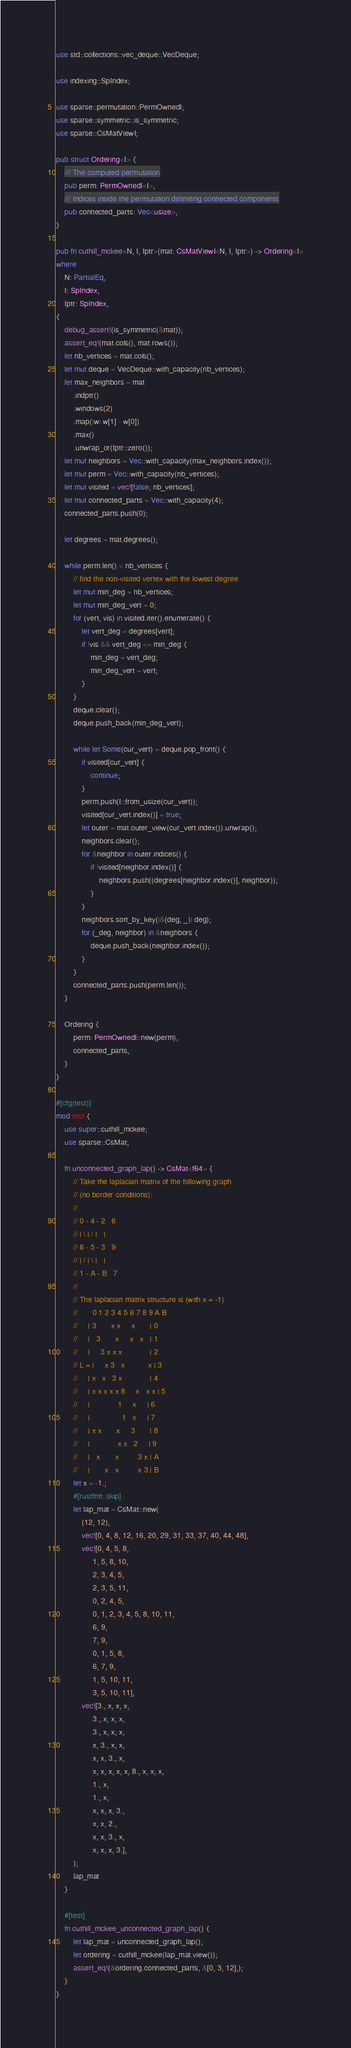Convert code to text. <code><loc_0><loc_0><loc_500><loc_500><_Rust_>use std::collections::vec_deque::VecDeque;

use indexing::SpIndex;

use sparse::permutation::PermOwnedI;
use sparse::symmetric::is_symmetric;
use sparse::CsMatViewI;

pub struct Ordering<I> {
    /// The computed permutation
    pub perm: PermOwnedI<I>,
    /// Indices inside the permutation delimiting connected components
    pub connected_parts: Vec<usize>,
}

pub fn cuthill_mckee<N, I, Iptr>(mat: CsMatViewI<N, I, Iptr>) -> Ordering<I>
where
    N: PartialEq,
    I: SpIndex,
    Iptr: SpIndex,
{
    debug_assert!(is_symmetric(&mat));
    assert_eq!(mat.cols(), mat.rows());
    let nb_vertices = mat.cols();
    let mut deque = VecDeque::with_capacity(nb_vertices);
    let max_neighbors = mat
        .indptr()
        .windows(2)
        .map(|w| w[1] - w[0])
        .max()
        .unwrap_or(Iptr::zero());
    let mut neighbors = Vec::with_capacity(max_neighbors.index());
    let mut perm = Vec::with_capacity(nb_vertices);
    let mut visited = vec![false; nb_vertices];
    let mut connected_parts = Vec::with_capacity(4);
    connected_parts.push(0);

    let degrees = mat.degrees();

    while perm.len() < nb_vertices {
        // find the non-visited vertex with the lowest degree
        let mut min_deg = nb_vertices;
        let mut min_deg_vert = 0;
        for (vert, vis) in visited.iter().enumerate() {
            let vert_deg = degrees[vert];
            if !vis && vert_deg <= min_deg {
                min_deg = vert_deg;
                min_deg_vert = vert;
            }
        }
        deque.clear();
        deque.push_back(min_deg_vert);

        while let Some(cur_vert) = deque.pop_front() {
            if visited[cur_vert] {
                continue;
            }
            perm.push(I::from_usize(cur_vert));
            visited[cur_vert.index()] = true;
            let outer = mat.outer_view(cur_vert.index()).unwrap();
            neighbors.clear();
            for &neighbor in outer.indices() {
                if !visited[neighbor.index()] {
                    neighbors.push((degrees[neighbor.index()], neighbor));
                }
            }
            neighbors.sort_by_key(|&(deg, _)| deg);
            for (_deg, neighbor) in &neighbors {
                deque.push_back(neighbor.index());
            }
        }
        connected_parts.push(perm.len());
    }

    Ordering {
        perm: PermOwnedI::new(perm),
        connected_parts,
    }
}

#[cfg(test)]
mod test {
    use super::cuthill_mckee;
    use sparse::CsMat;

    fn unconnected_graph_lap() -> CsMat<f64> {
        // Take the laplacian matrix of the following graph
        // (no border conditions):
        //
        // 0 - 4 - 2   6
        // | \ | / |   |
        // 8 - 5 - 3   9
        // | / | \ |   |
        // 1 - A - B   7
        //
        // The laplacian matrix structure is (with x = -1)
        //       0 1 2 3 4 5 6 7 8 9 A B
        //     | 3       x x     x       | 0
        //     |   3       x     x   x   | 1
        //     |     3 x x x             | 2
        // L = |     x 3   x           x | 3
        //     | x   x   3 x             | 4
        //     | x x x x x 8     x   x x | 5
        //     |             1     x     | 6
        //     |               1   x     | 7
        //     | x x       x     3       | 8
        //     |             x x   2     | 9
        //     |   x       x         3 x | A
        //     |       x   x         x 3 | B
        let x = -1.;
        #[rustfmt::skip]
        let lap_mat = CsMat::new(
            (12, 12),
            vec![0, 4, 8, 12, 16, 20, 29, 31, 33, 37, 40, 44, 48],
            vec![0, 4, 5, 8,
                 1, 5, 8, 10,
                 2, 3, 4, 5,
                 2, 3, 5, 11,
                 0, 2, 4, 5,
                 0, 1, 2, 3, 4, 5, 8, 10, 11,
                 6, 9,
                 7, 9,
                 0, 1, 5, 8,
                 6, 7, 9,
                 1, 5, 10, 11,
                 3, 5, 10, 11],
            vec![3., x, x, x,
                 3., x, x, x,
                 3., x, x, x,
                 x, 3., x, x,
                 x, x, 3., x,
                 x, x, x, x, x, 8., x, x, x,
                 1., x,
                 1., x,
                 x, x, x, 3.,
                 x, x, 2.,
                 x, x, 3., x,
                 x, x, x, 3.],
        );
        lap_mat
    }

    #[test]
    fn cuthill_mckee_unconnected_graph_lap() {
        let lap_mat = unconnected_graph_lap();
        let ordering = cuthill_mckee(lap_mat.view());
        assert_eq!(&ordering.connected_parts, &[0, 3, 12],);
    }
}
</code> 